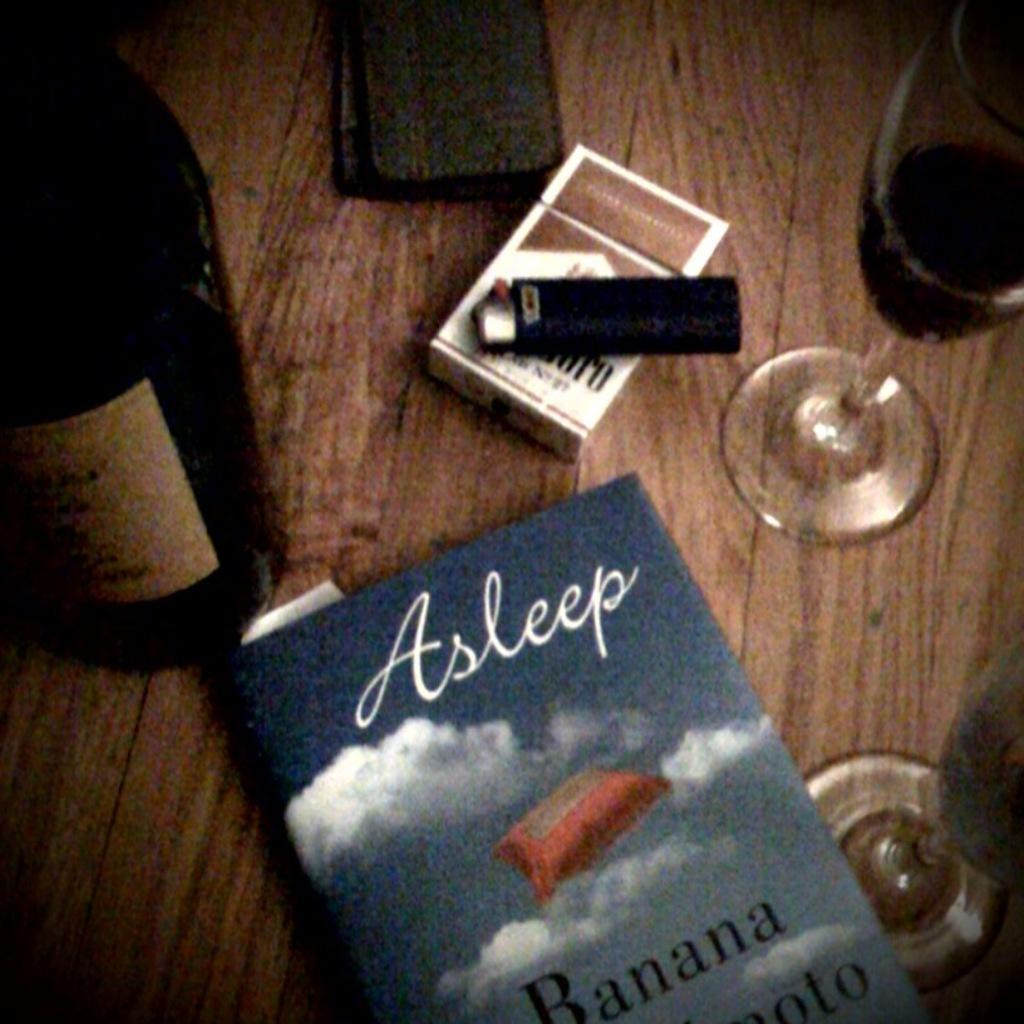Provide a one-sentence caption for the provided image. table contains Marlboro cigarettes, wine, a wallet and the book Asleep. 